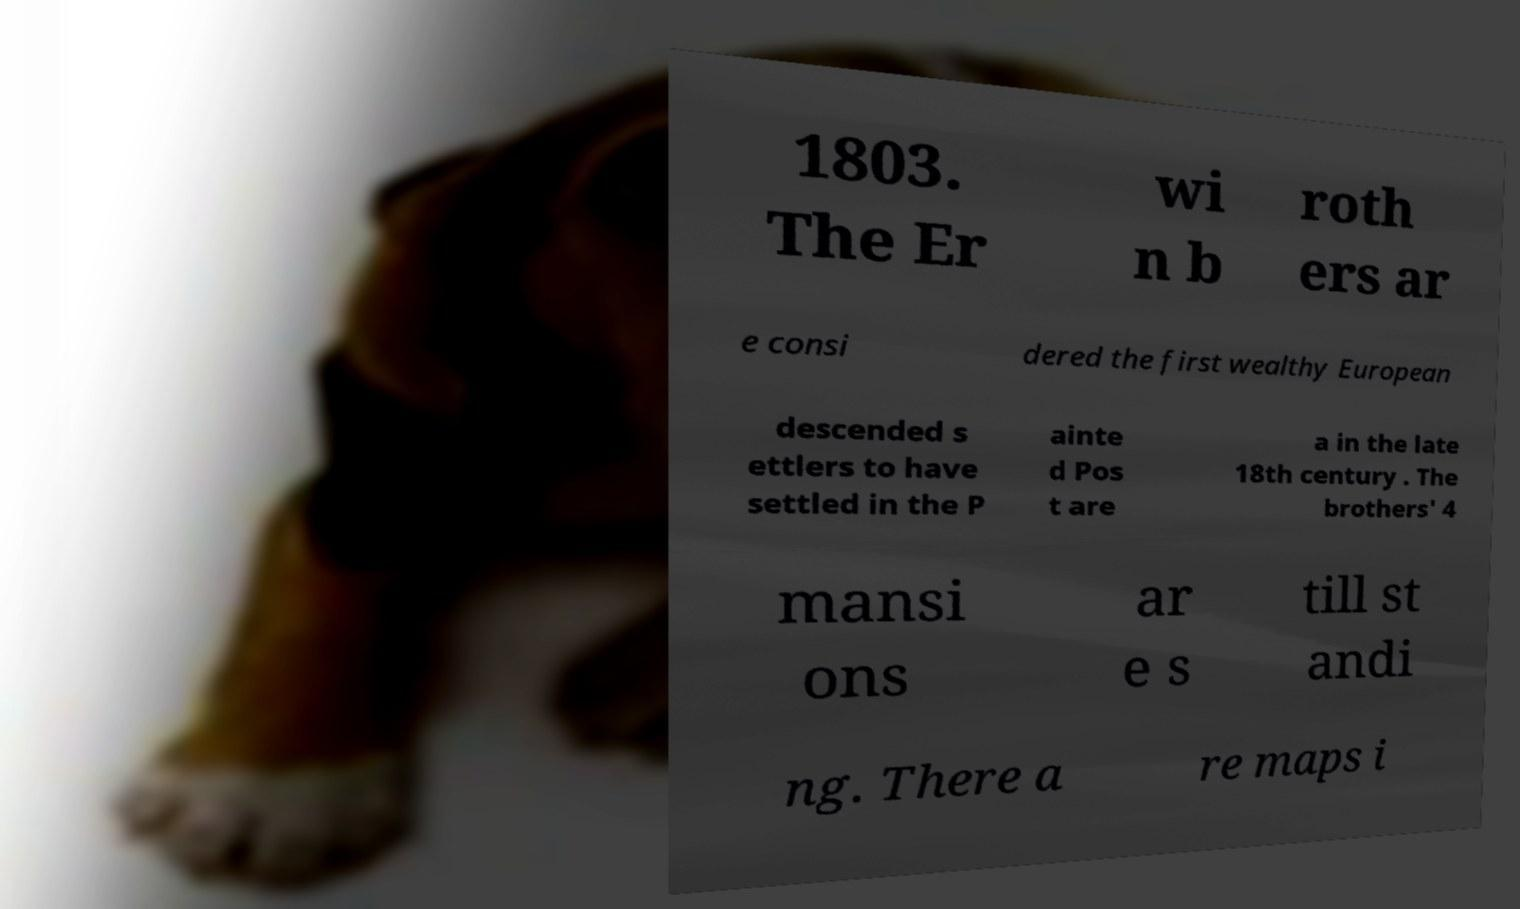I need the written content from this picture converted into text. Can you do that? 1803. The Er wi n b roth ers ar e consi dered the first wealthy European descended s ettlers to have settled in the P ainte d Pos t are a in the late 18th century . The brothers' 4 mansi ons ar e s till st andi ng. There a re maps i 